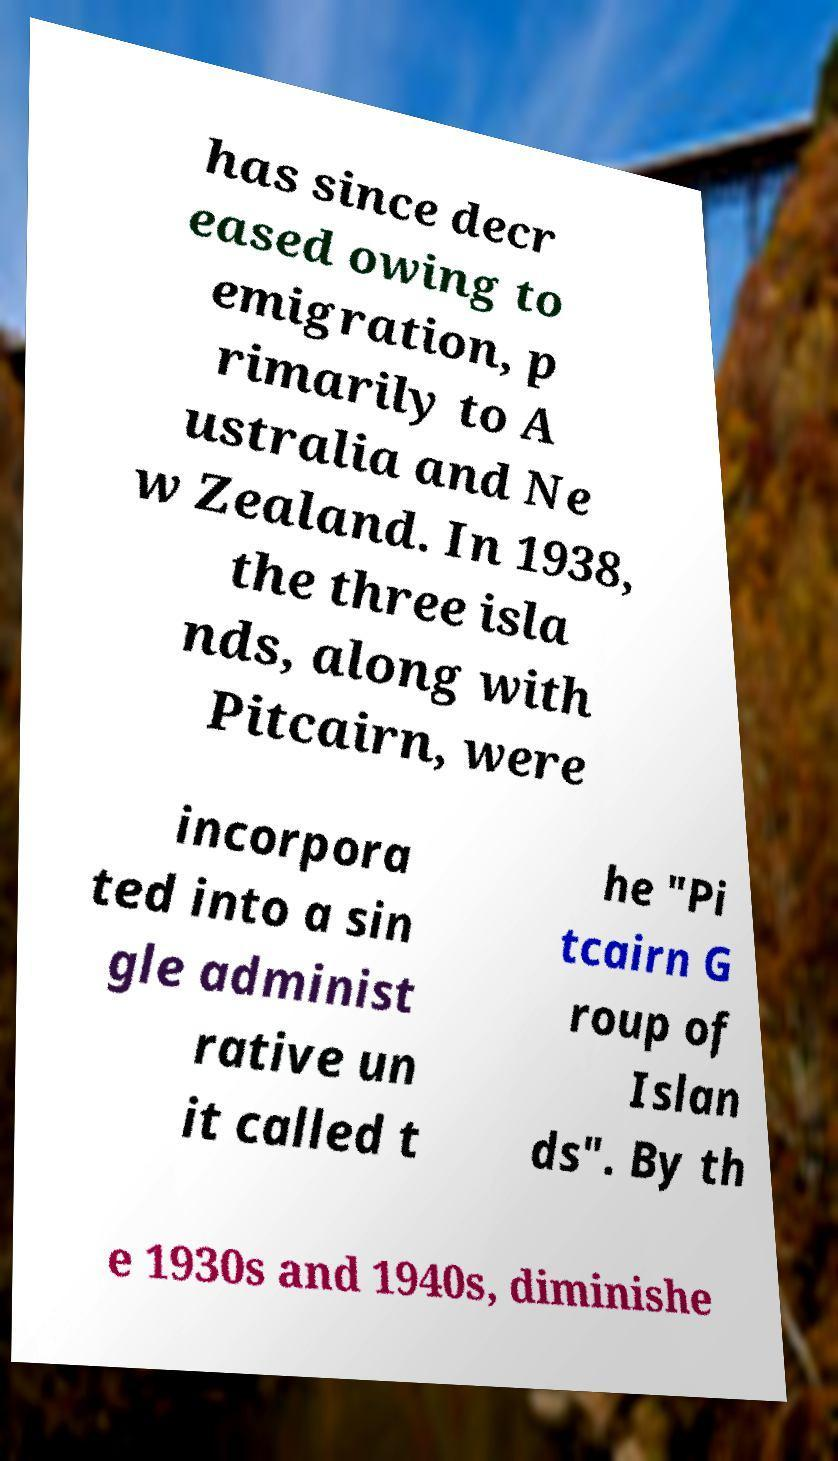I need the written content from this picture converted into text. Can you do that? has since decr eased owing to emigration, p rimarily to A ustralia and Ne w Zealand. In 1938, the three isla nds, along with Pitcairn, were incorpora ted into a sin gle administ rative un it called t he "Pi tcairn G roup of Islan ds". By th e 1930s and 1940s, diminishe 